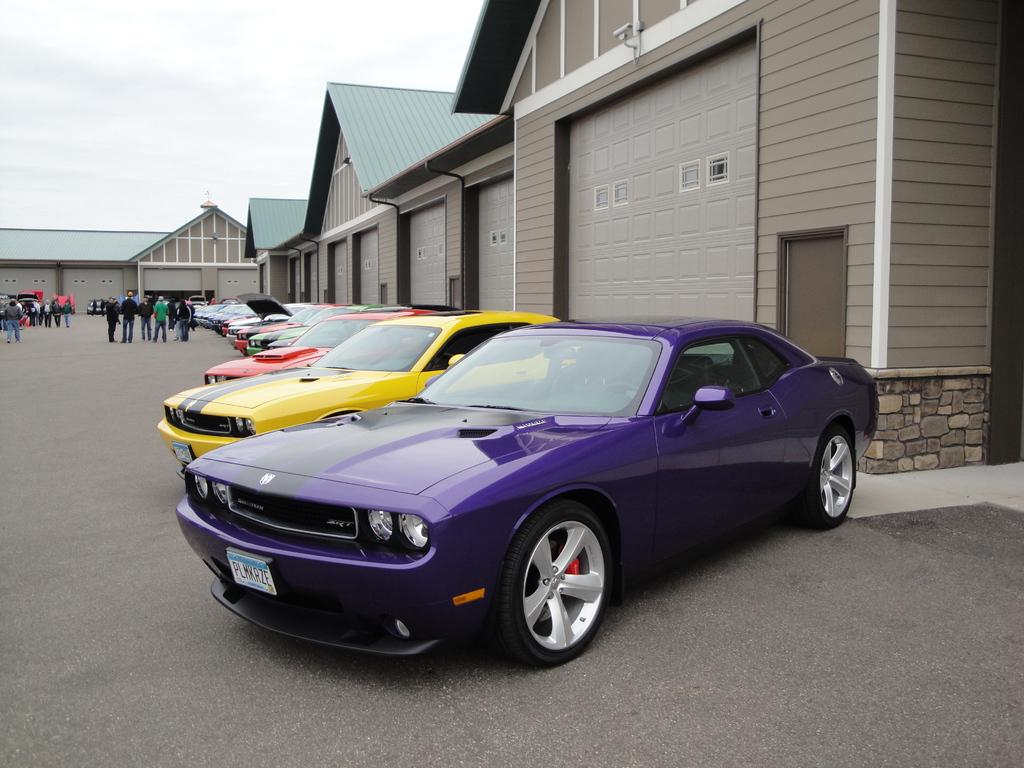What can be seen on the road in the image? There are cars parked on the road and people standing on the road. What type of structures are visible in the image? There are buildings visible in the image. What is the condition of the sky in the image? The sky is clear and visible at the top of the image. How many frogs are sitting on the cars in the image? There are no frogs present in the image; it features cars parked on the road and people standing on the road. What type of ice can be seen melting on the buildings in the image? There is no ice present in the image; the buildings are visible in their normal state. 